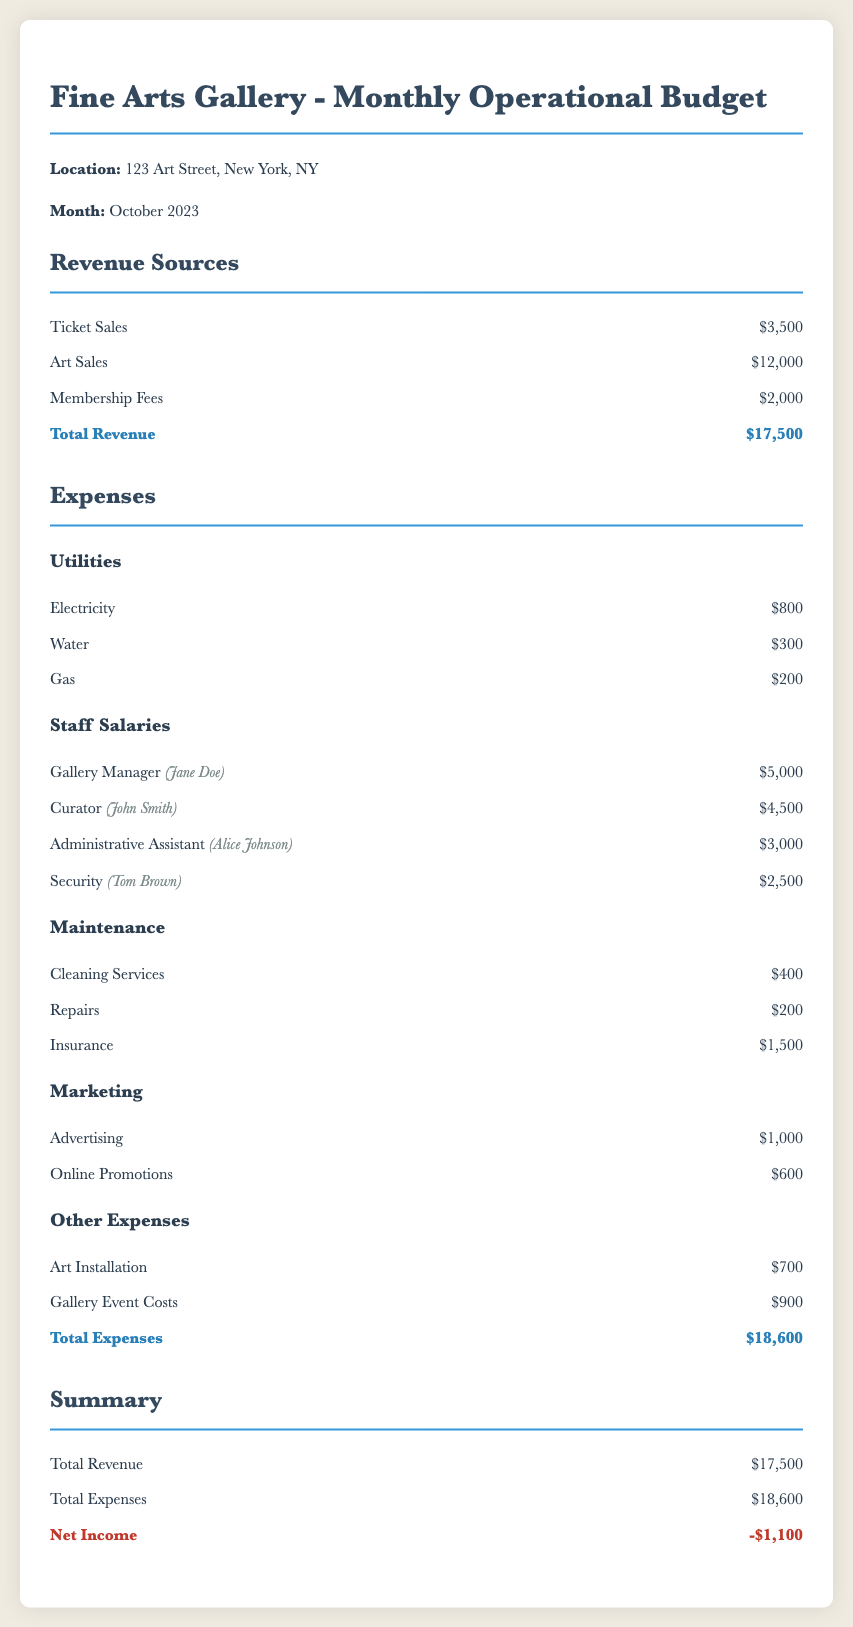What is the location of the gallery? The document specifies the address of the gallery as 123 Art Street, New York, NY.
Answer: 123 Art Street, New York, NY What is the total revenue for October 2023? The total revenue is calculated from the sum of ticket sales, art sales, and membership fees, which amounts to $3,500 + $12,000 + $2,000.
Answer: $17,500 Who is the gallery manager? The document names Jane Doe as the gallery manager, listed under staff salaries.
Answer: Jane Doe How much is allocated for electricity? The amount allocated for electricity is stated clearly in the utilities section of the document.
Answer: $800 What is the total amount spent on staff salaries? The total staff salaries can be calculated by summing the individual salaries of the staff members in the document, which adds up to $15,000.
Answer: $15,000 What are the total expenses for the gallery? The total expenses are listed at the bottom of the expenses section, which includes all categories combined.
Answer: $18,600 What is the net income for October 2023? The net income is derived from subtracting total expenses from total revenue, resulting in $17,500 - $18,600.
Answer: -$1,100 How much is allocated for marketing expenses? The document lists the marketing section expenses, which include advertising and online promotions totaling to $1,600.
Answer: $1,600 What is the cost for cleaning services? The cost for cleaning services is specified in the maintenance section as part of the monthly expenses.
Answer: $400 